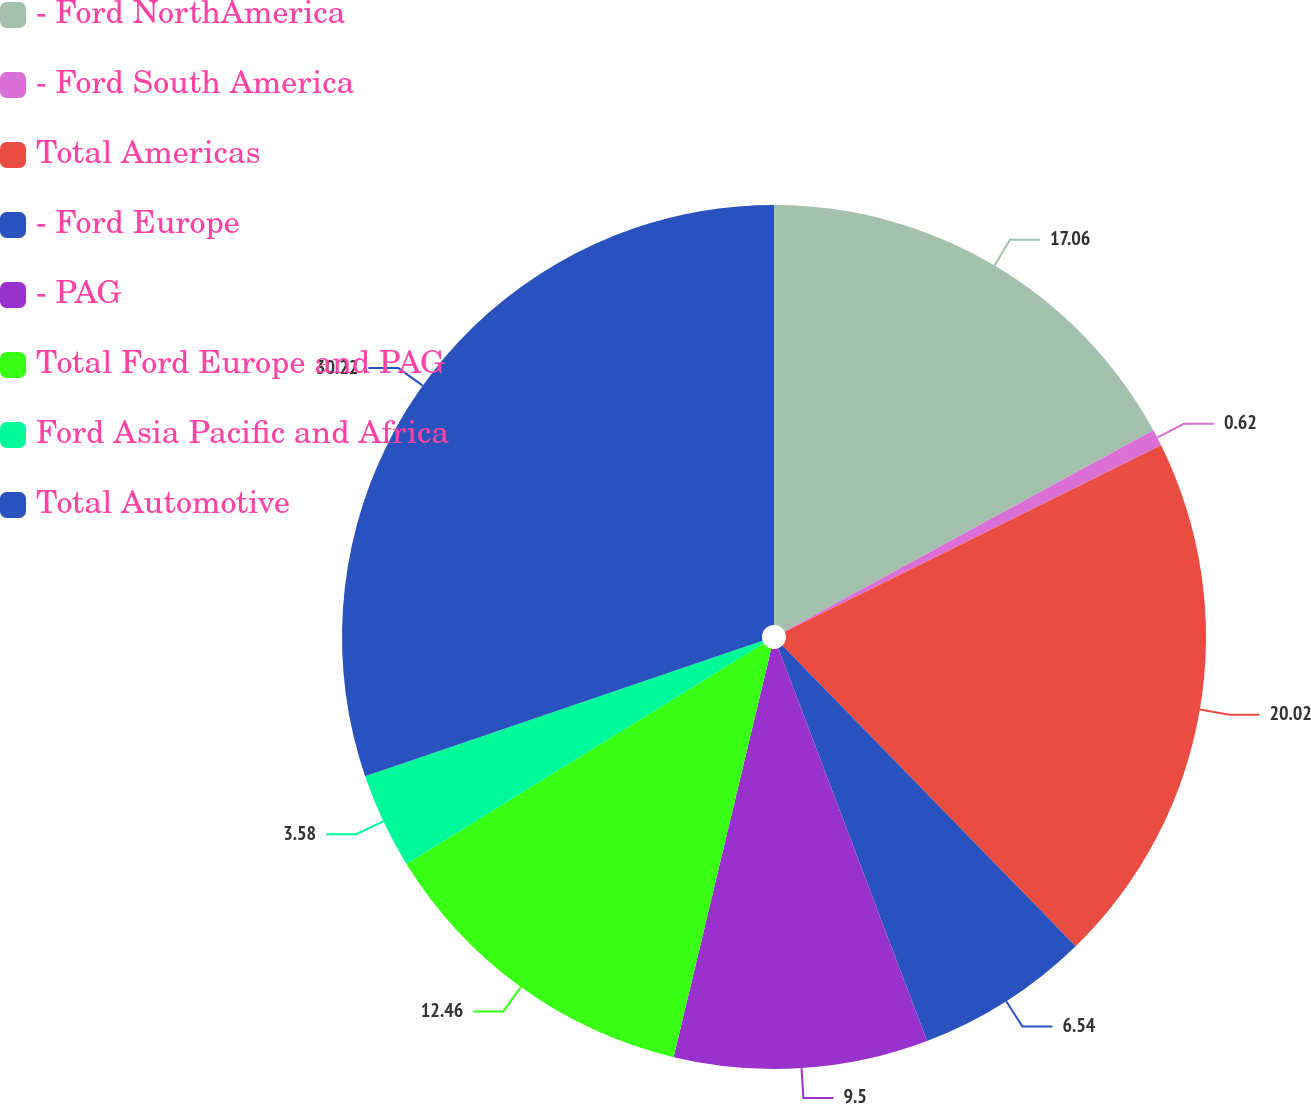<chart> <loc_0><loc_0><loc_500><loc_500><pie_chart><fcel>- Ford NorthAmerica<fcel>- Ford South America<fcel>Total Americas<fcel>- Ford Europe<fcel>- PAG<fcel>Total Ford Europe and PAG<fcel>Ford Asia Pacific and Africa<fcel>Total Automotive<nl><fcel>17.06%<fcel>0.62%<fcel>20.02%<fcel>6.54%<fcel>9.5%<fcel>12.46%<fcel>3.58%<fcel>30.23%<nl></chart> 